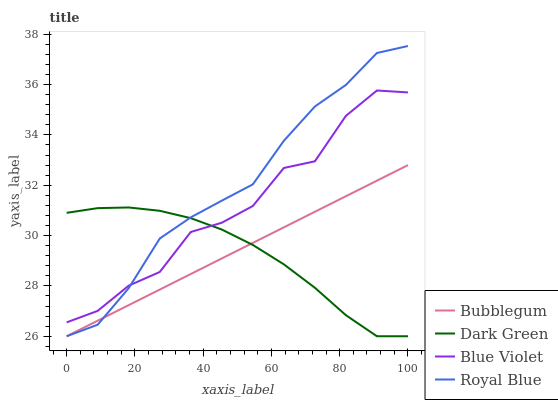Does Dark Green have the minimum area under the curve?
Answer yes or no. Yes. Does Royal Blue have the maximum area under the curve?
Answer yes or no. Yes. Does Blue Violet have the minimum area under the curve?
Answer yes or no. No. Does Blue Violet have the maximum area under the curve?
Answer yes or no. No. Is Bubblegum the smoothest?
Answer yes or no. Yes. Is Blue Violet the roughest?
Answer yes or no. Yes. Is Blue Violet the smoothest?
Answer yes or no. No. Is Bubblegum the roughest?
Answer yes or no. No. Does Blue Violet have the lowest value?
Answer yes or no. No. Does Blue Violet have the highest value?
Answer yes or no. No. Is Bubblegum less than Blue Violet?
Answer yes or no. Yes. Is Blue Violet greater than Bubblegum?
Answer yes or no. Yes. Does Bubblegum intersect Blue Violet?
Answer yes or no. No. 